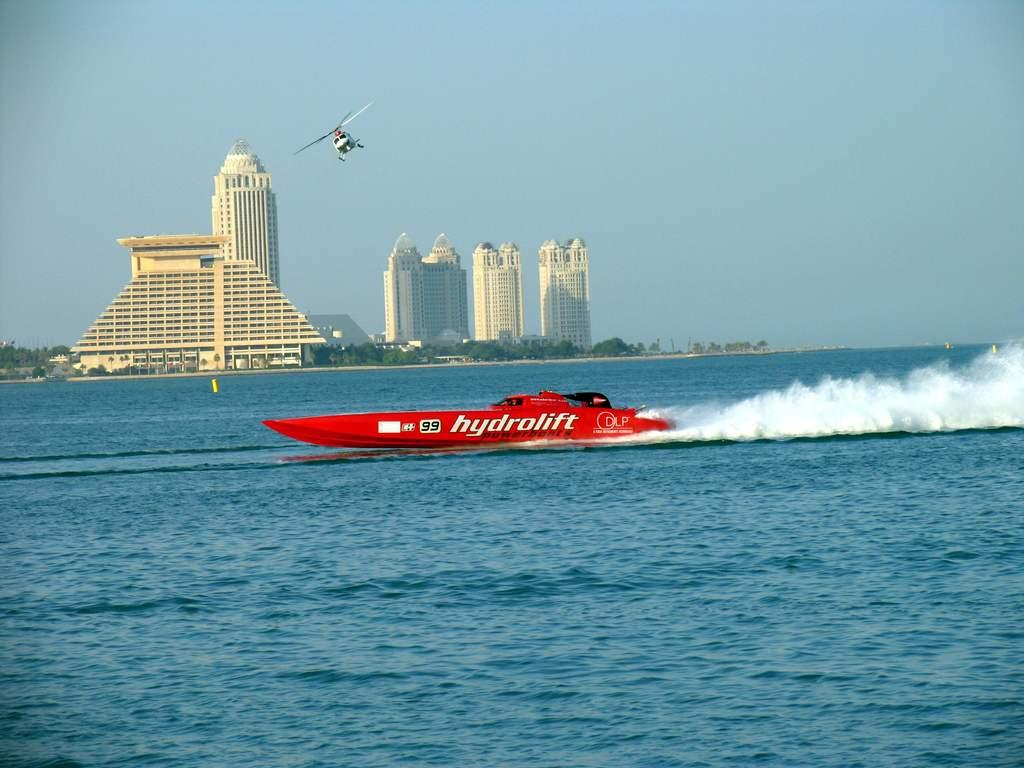What is the main subject of the image? The main subject of the image is a boat on the water. What else is happening in the image? A helicopter is flying in the image. What can be seen in the background of the image? There are buildings, trees, and the sky visible in the background of the image. Are there any objects on the water besides the boat? Yes, there are objects on the water in the image. What type of agreement is being discussed in the image? There is no indication of any agreement being discussed in the image; it primarily features a boat on the water and a helicopter flying. What is being served for lunch in the image? There is no mention of lunch or any food in the image. 